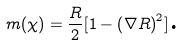<formula> <loc_0><loc_0><loc_500><loc_500>m ( \chi ) = \frac { R } { 2 } [ 1 - \left ( \nabla R \right ) ^ { 2 } ] \text {.}</formula> 